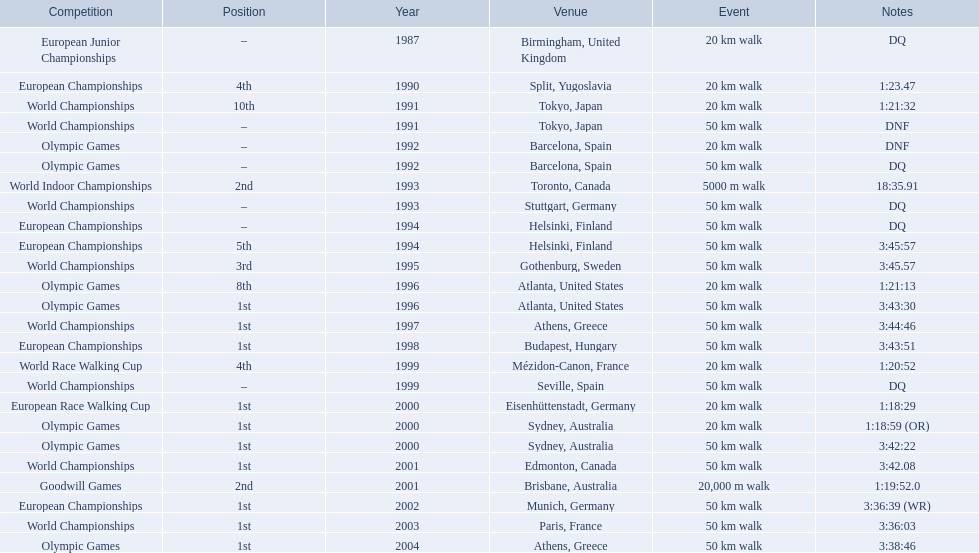In 1990 what position did robert korzeniowski place? 4th. In 1993 what was robert korzeniowski's place in the world indoor championships? 2nd. How long did the 50km walk in 2004 olympic cost? 3:38:46. 